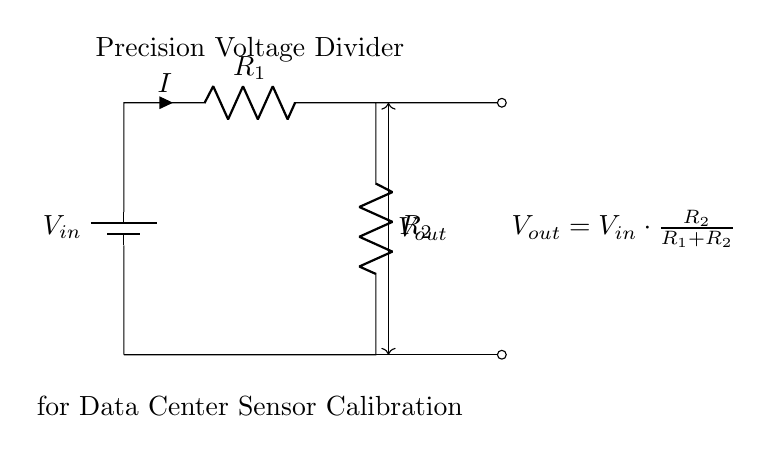What is the total resistance in the circuit? The total resistance in a voltage divider is the sum of the individual resistances, R1 and R2. Therefore, the total resistance is R1 + R2.
Answer: R1 + R2 What is the output voltage formula? The output voltage is given by the formula Vout = Vin × (R2 / (R1 + R2)), which describes how the input voltage is divided based on the resistor values.
Answer: Vout = Vin × (R2 / (R1 + R2)) What type of circuit is represented? The circuit diagram depicts a voltage divider, which is specifically used to lower voltage levels.
Answer: Voltage divider What is the input voltage denoted as? The input voltage is represented by the node labeled V_in in the circuit diagram.
Answer: V_in What is the purpose of the precision voltage divider? The purpose of the precision voltage divider is to calibrate data center voltage sensors, ensuring accurate measurements of voltage levels.
Answer: To calibrate data center voltage sensors How does increasing R2 affect Vout? Increasing R2 increases the output voltage Vout, as it is directly proportional to R2 in the voltage divider formula.
Answer: Vout increases What is the current flowing in the circuit? The current flowing through the circuit can be denoted as I, which is the same through both resistors in a series configuration.
Answer: I 